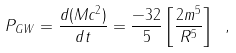Convert formula to latex. <formula><loc_0><loc_0><loc_500><loc_500>P _ { G W } = \frac { d ( M c ^ { 2 } ) } { d t } = \frac { - 3 2 } { 5 } \left [ \frac { 2 m ^ { 5 } } { R ^ { 5 } } \right ] \ ,</formula> 